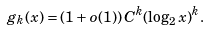<formula> <loc_0><loc_0><loc_500><loc_500>g _ { k } ( x ) = ( 1 + o ( 1 ) ) \, C ^ { k } ( \log _ { 2 } x ) ^ { k } .</formula> 